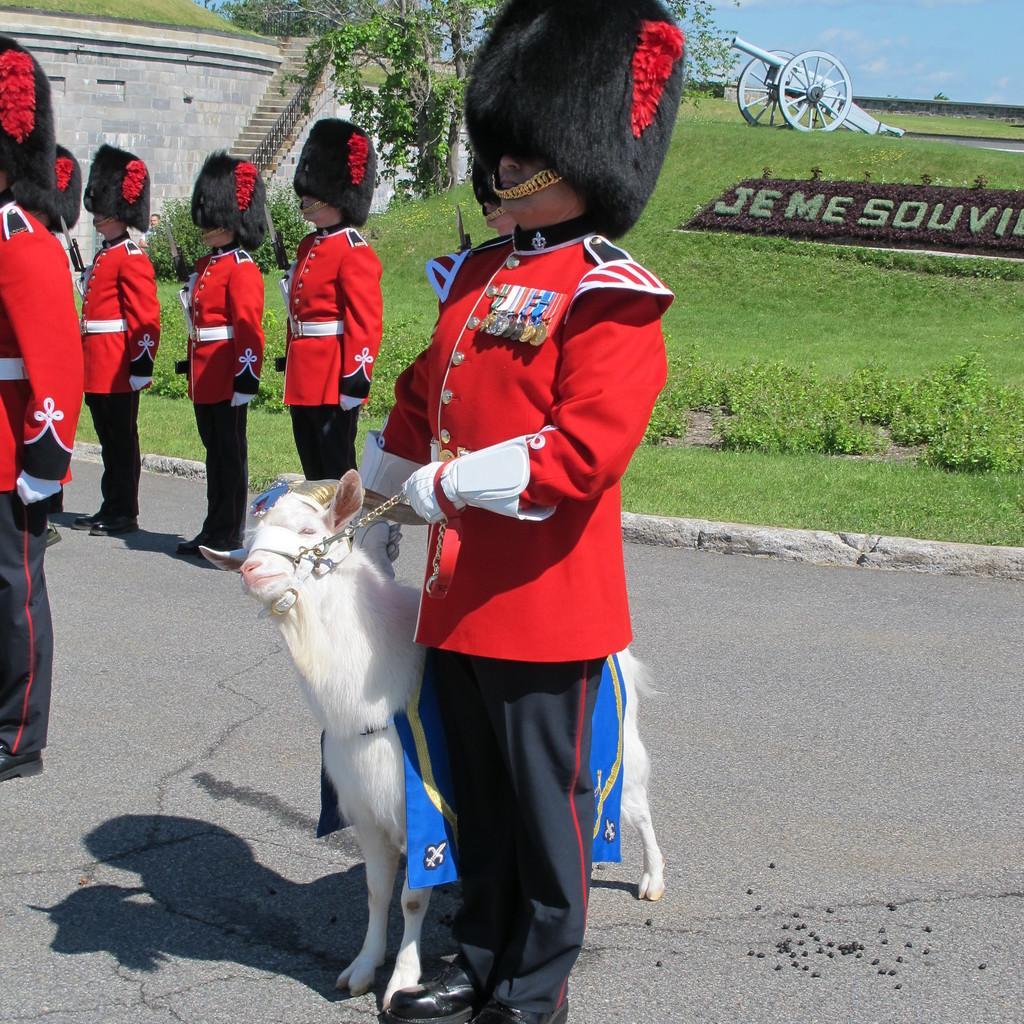Describe this image in one or two sentences. We can see a man is standing and holding the belt which is tied to an animal are on the road. On the left side there are few persons standing on the road. In the background we can see grass, trees and old cannon on the ground, wall, steps and clouds in the sky. 